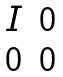Convert formula to latex. <formula><loc_0><loc_0><loc_500><loc_500>\begin{matrix} I & 0 \\ 0 & 0 \end{matrix}</formula> 